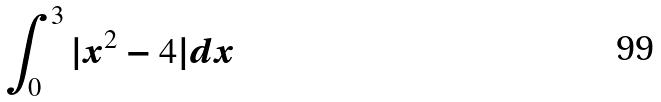<formula> <loc_0><loc_0><loc_500><loc_500>\int _ { 0 } ^ { 3 } | x ^ { 2 } - 4 | d x</formula> 